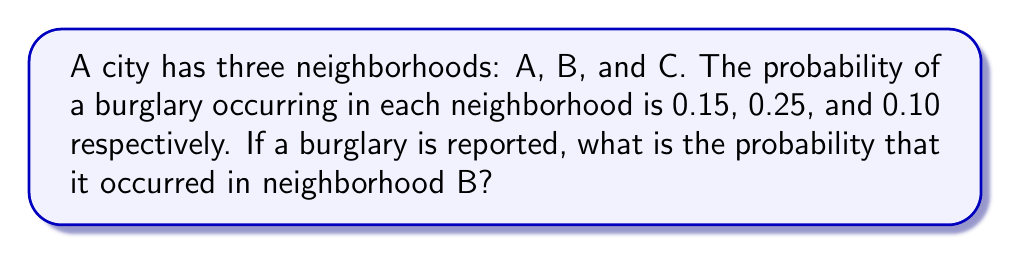What is the answer to this math problem? To solve this problem, we'll use the concept of conditional probability and the law of total probability.

Step 1: Let's define our events:
- Let A, B, and C represent the event of a burglary occurring in neighborhoods A, B, and C respectively.
- Let R represent the event that a burglary is reported.

Step 2: We're given the following probabilities:
$P(A) = 0.15$
$P(B) = 0.25$
$P(C) = 0.10$

Step 3: We need to find $P(B|R)$, which is the probability that the burglary occurred in neighborhood B given that a burglary was reported.

Step 4: Using Bayes' theorem:

$$P(B|R) = \frac{P(R|B)P(B)}{P(R)}$$

Step 5: We assume that all burglaries are reported, so $P(R|B) = 1$

Step 6: Calculate $P(R)$ using the law of total probability:
$$P(R) = P(R|A)P(A) + P(R|B)P(B) + P(R|C)P(C)$$
$$P(R) = 1 \cdot 0.15 + 1 \cdot 0.25 + 1 \cdot 0.10 = 0.50$$

Step 7: Now we can plug everything into Bayes' theorem:

$$P(B|R) = \frac{1 \cdot 0.25}{0.50} = 0.50$$

Therefore, the probability that the reported burglary occurred in neighborhood B is 0.50 or 50%.
Answer: 0.50 